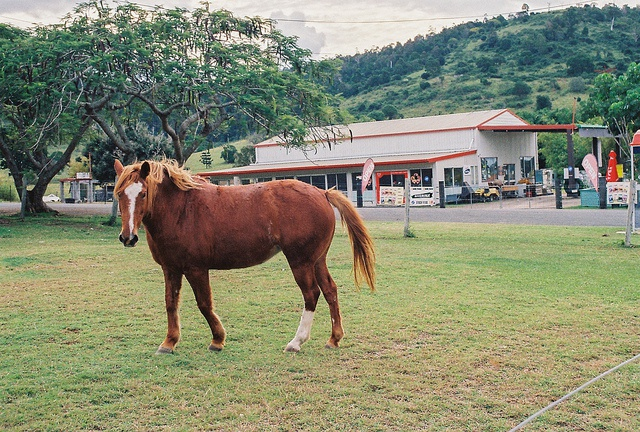Describe the objects in this image and their specific colors. I can see a horse in lightgray, maroon, black, and brown tones in this image. 